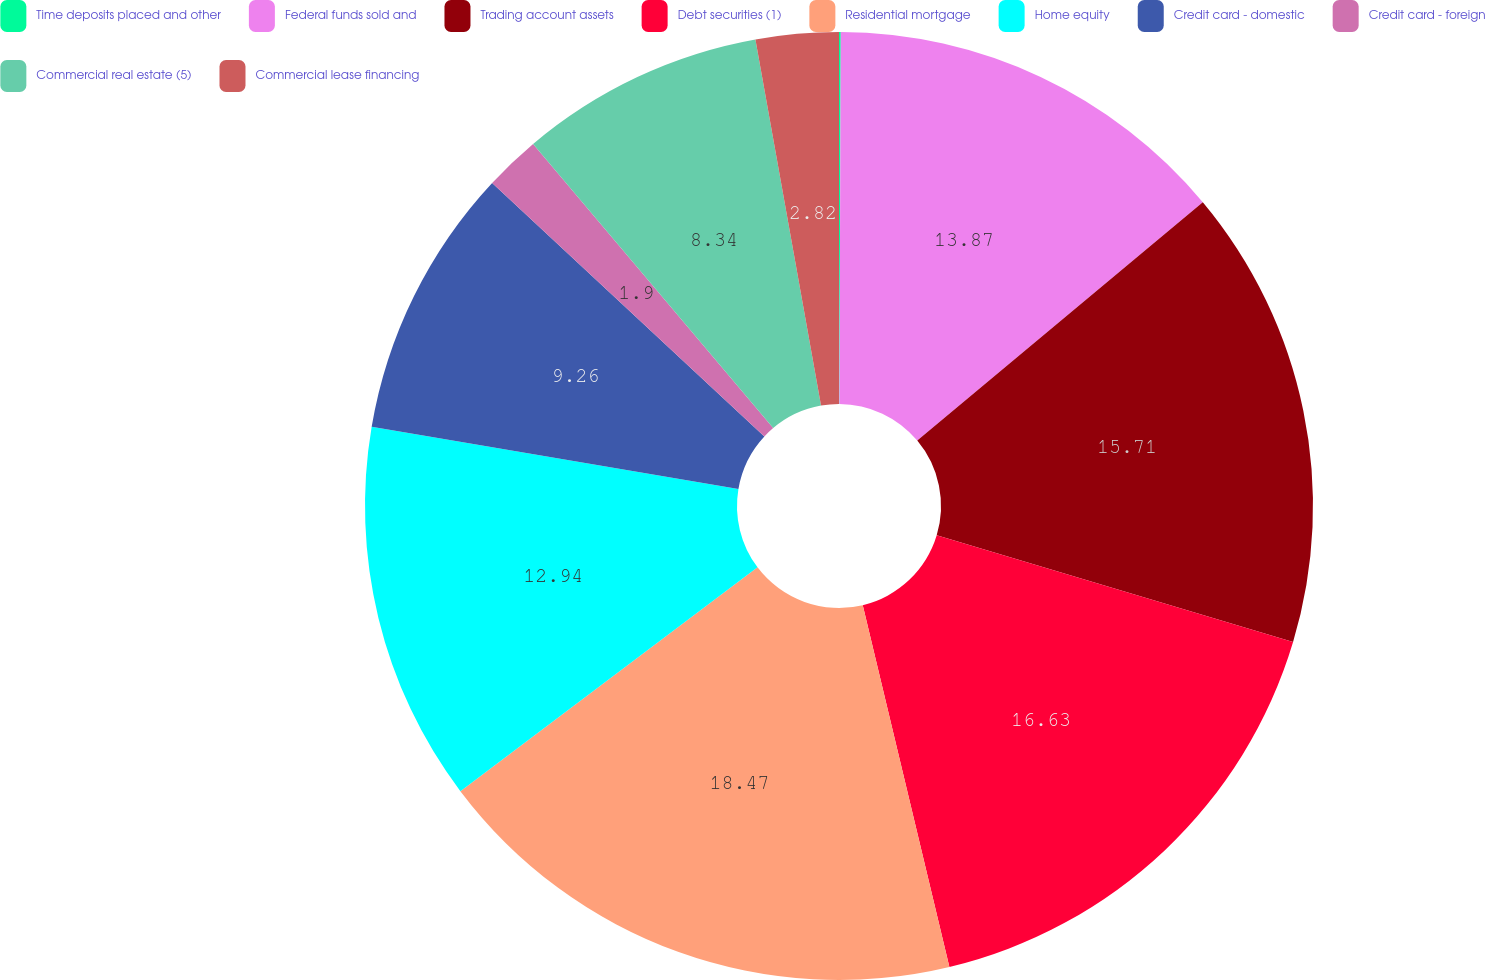Convert chart. <chart><loc_0><loc_0><loc_500><loc_500><pie_chart><fcel>Time deposits placed and other<fcel>Federal funds sold and<fcel>Trading account assets<fcel>Debt securities (1)<fcel>Residential mortgage<fcel>Home equity<fcel>Credit card - domestic<fcel>Credit card - foreign<fcel>Commercial real estate (5)<fcel>Commercial lease financing<nl><fcel>0.06%<fcel>13.86%<fcel>15.7%<fcel>16.62%<fcel>18.46%<fcel>12.94%<fcel>9.26%<fcel>1.9%<fcel>8.34%<fcel>2.82%<nl></chart> 